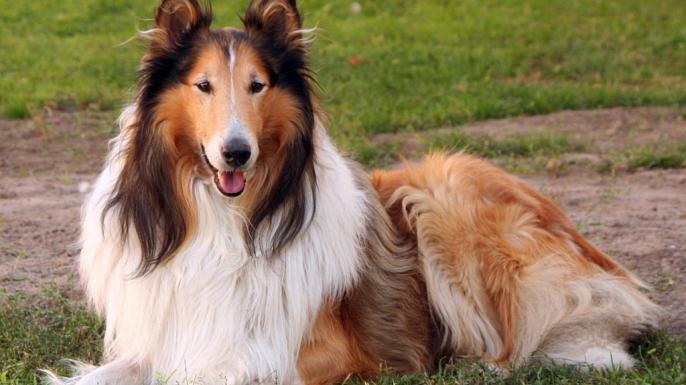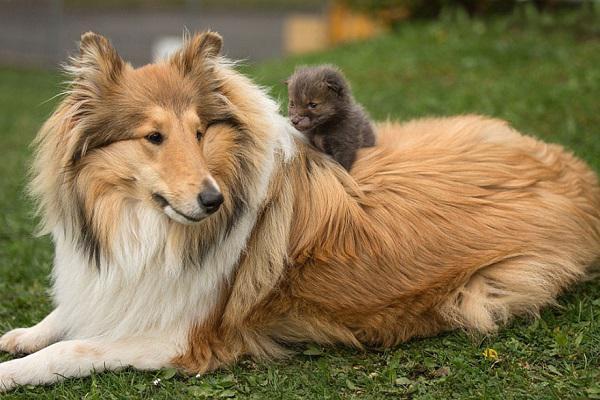The first image is the image on the left, the second image is the image on the right. Given the left and right images, does the statement "The dogs on the left are running." hold true? Answer yes or no. No. 